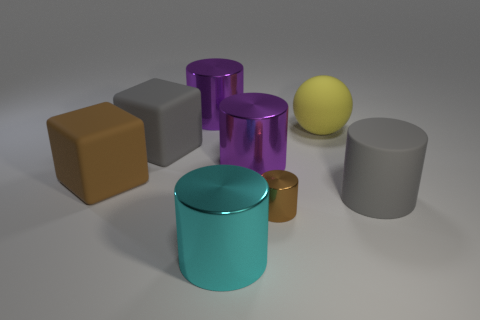Subtract 1 cylinders. How many cylinders are left? 4 Subtract all brown cylinders. How many cylinders are left? 4 Subtract all matte cylinders. How many cylinders are left? 4 Subtract all green cylinders. Subtract all cyan blocks. How many cylinders are left? 5 Add 1 big brown objects. How many objects exist? 9 Subtract all spheres. How many objects are left? 7 Subtract 0 cyan spheres. How many objects are left? 8 Subtract all gray cylinders. Subtract all shiny cylinders. How many objects are left? 3 Add 1 small brown metal objects. How many small brown metal objects are left? 2 Add 1 brown things. How many brown things exist? 3 